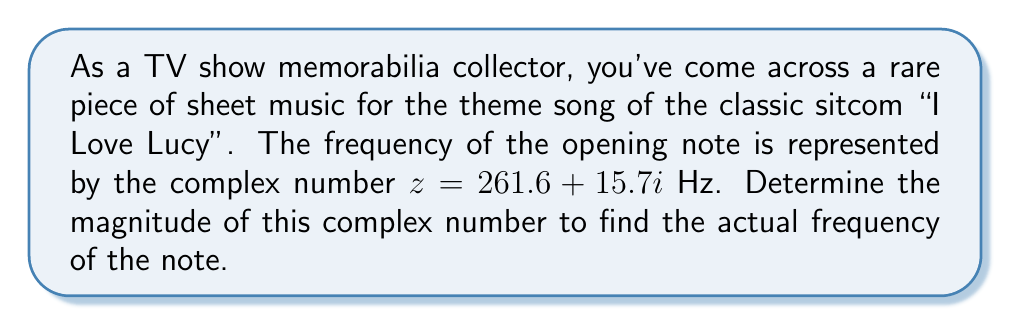Provide a solution to this math problem. To find the magnitude of a complex number $z = a + bi$, we use the formula:

$$|z| = \sqrt{a^2 + b^2}$$

Where $|z|$ represents the magnitude of the complex number.

For our given complex number $z = 261.6 + 15.7i$:
$a = 261.6$
$b = 15.7$

Let's substitute these values into the formula:

$$|z| = \sqrt{(261.6)^2 + (15.7)^2}$$

Now, let's calculate:

1) First, square both numbers:
   $(261.6)^2 = 68,434.56$
   $(15.7)^2 = 246.49$

2) Add these squared values:
   $68,434.56 + 246.49 = 68,681.05$

3) Take the square root of the sum:
   $\sqrt{68,681.05} \approx 262.07$

Therefore, the magnitude of the complex number, which represents the actual frequency of the opening note, is approximately 262.07 Hz.
Answer: $|z| \approx 262.07$ Hz 